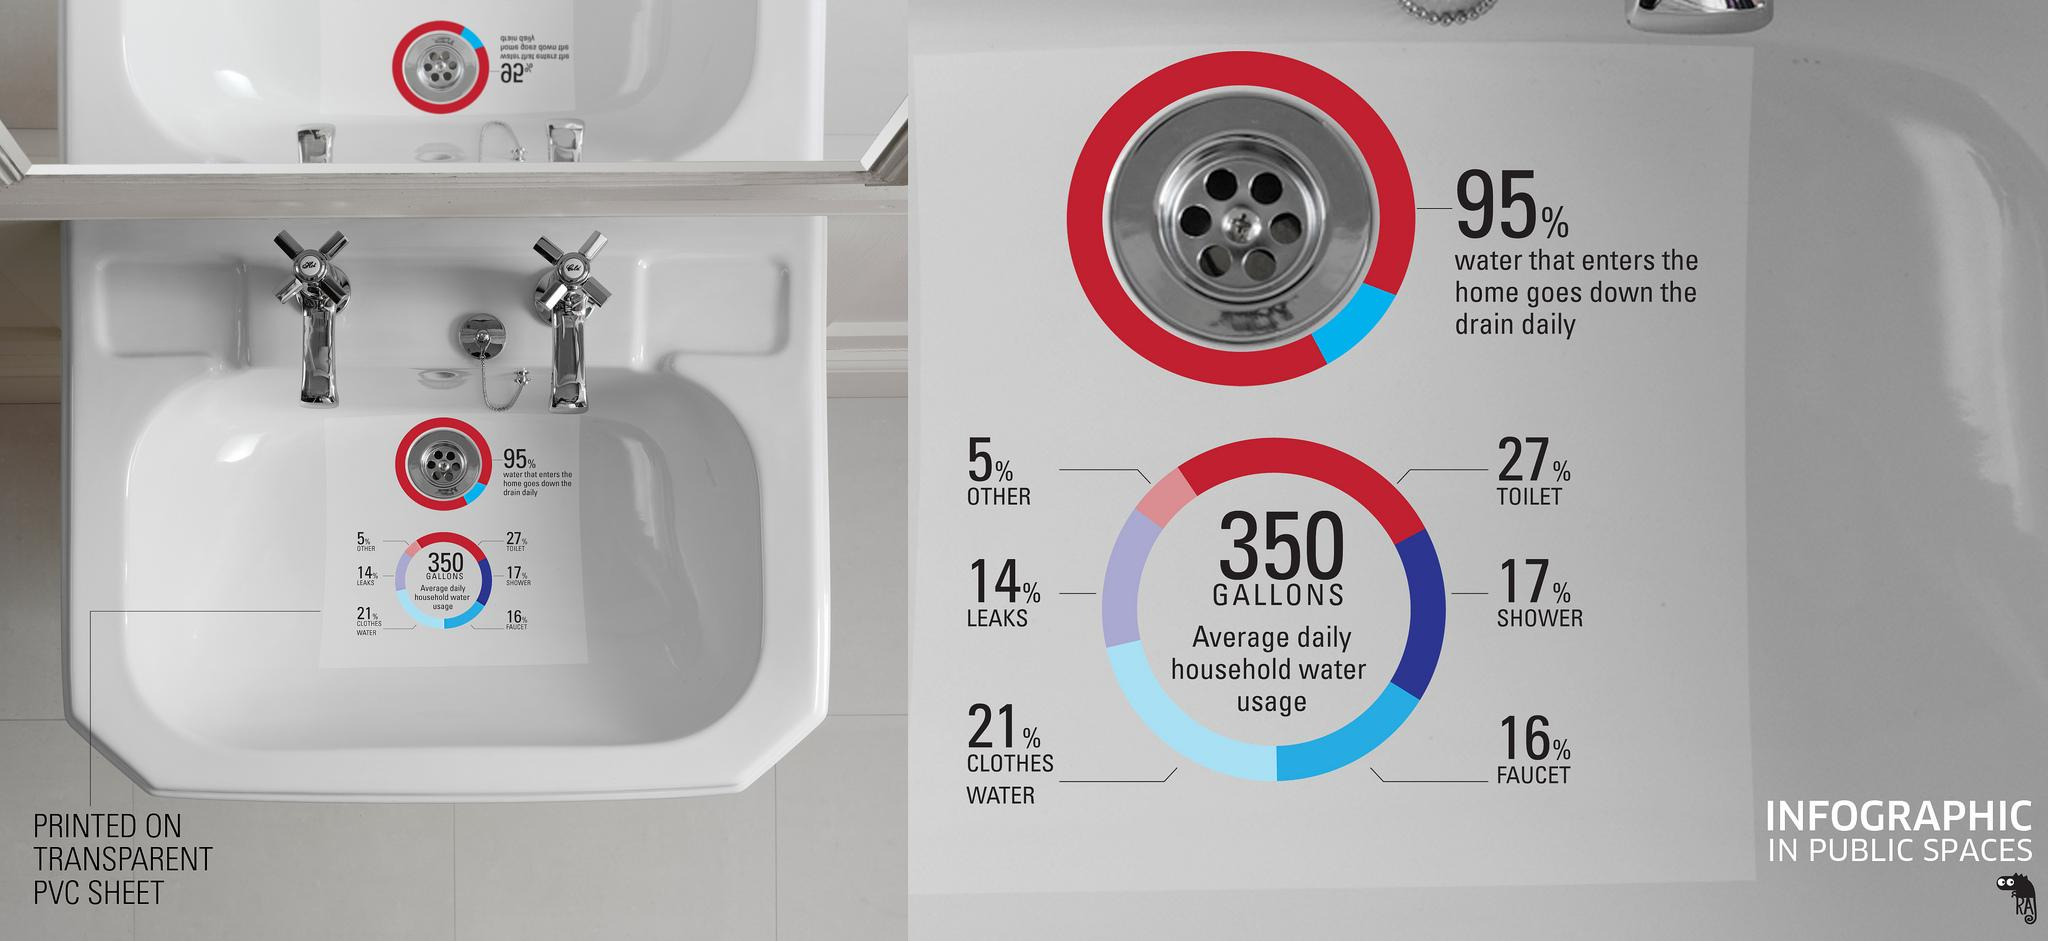Highlight a few significant elements in this photo. The toilet is the part of the home that consumes the most amount of water. 